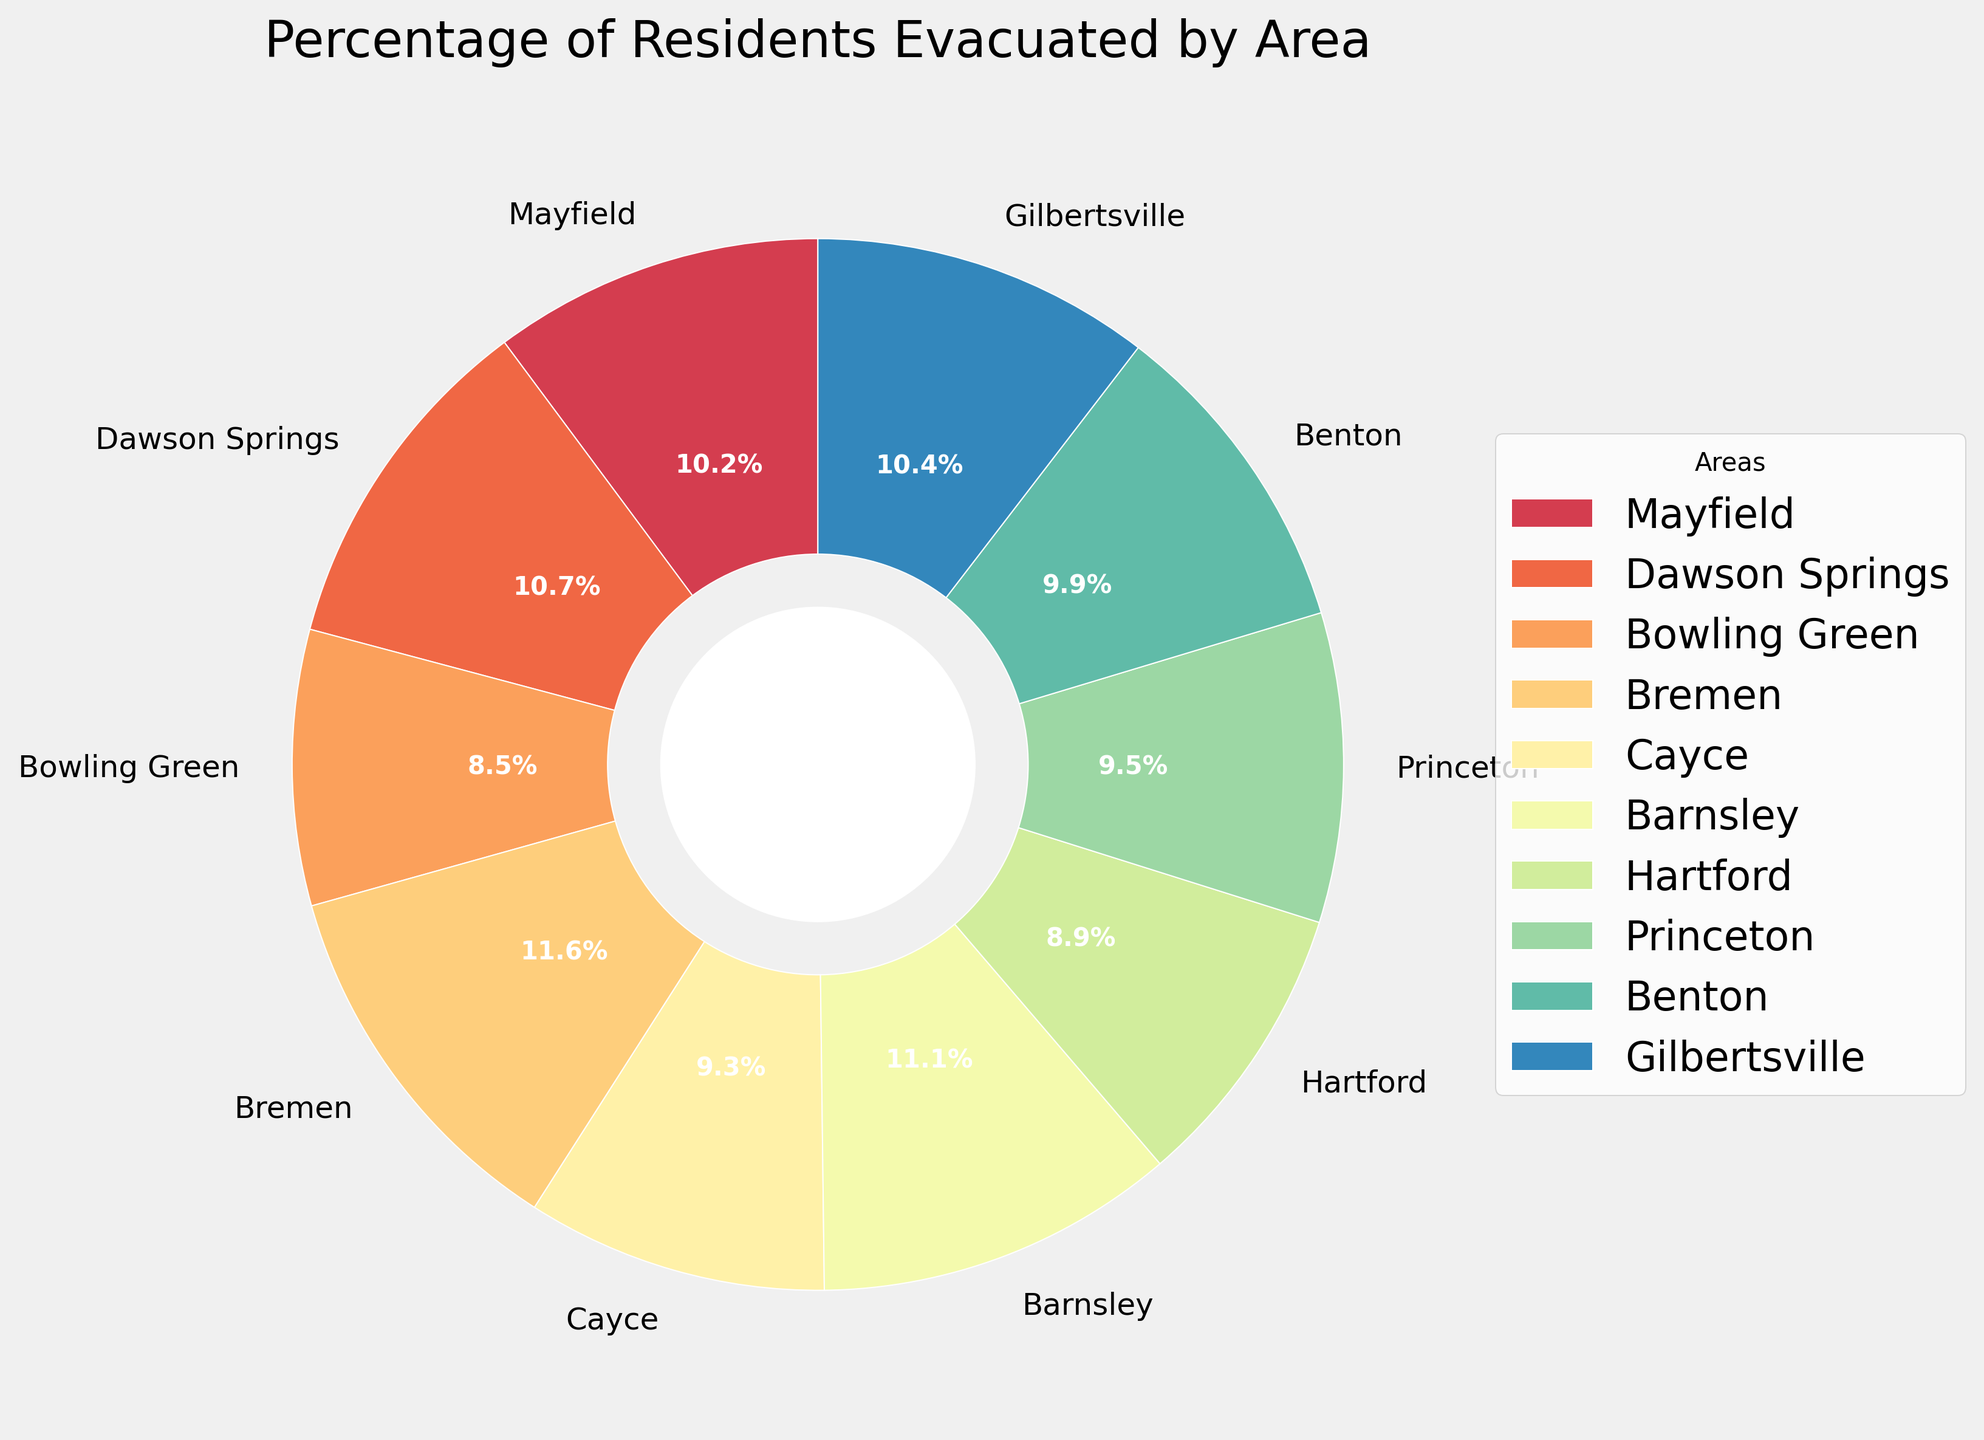Which area has the highest percentage of residents who evacuated? The highest percentage can be identified by observing the largest wedge on the pie chart. Bremen has the largest wedge, indicating the highest percentage of evacuations at 89%.
Answer: Bremen Which area has the lowest percentage of residents who evacuated? The lowest percentage can be determined by observing the smallest wedge on the pie chart. Bowling Green has the smallest wedge, indicating the lowest percentage of evacuations at 65%.
Answer: Bowling Green How many areas have an evacuation percentage of 80% or above? Observe the wedges and their respective labels to count areas with evacuation percentages of 80% or more. There are four such areas: Dawson Springs (82%), Bremen (89%), Barnsley (85%), and Gilbertsville (80%).
Answer: 4 What is the average percentage of residents who evacuated across all areas? Sum all the percentages and then divide by the number of areas. The sum is 78 + 82 + 65 + 89 + 71 + 85 + 68 + 73 + 76 + 80 = 767. There are 10 areas, so the average is 767/10 = 76.7%.
Answer: 76.7% Is the percentage of residents who evacuated from Mayfield greater than that of Princeton and Benton combined? Mayfield has 78%. Princeton has 73% and Benton has 76%, combinedly 73 + 76 = 149%. 78% is not greater than 149%.
Answer: No What is the difference in evacuation percentage between Dawson Springs and Hartford? Dawson Springs has 82% and Hartford has 68%. The difference is 82 - 68 = 14%.
Answer: 14% Is the evacuation percentage from Barnsley less than that of Bremen? Barnsley has 85% and Bremen has 89%. Since 85% is less than 89%, yes, Barnsley has a lower evacuation percentage.
Answer: Yes Which area has an evacuation percentage closest to the average percentage of all areas? The average evacuation percentage is 76.7%. Comparing each area's percentage to this value, Princeton at 73% and Benton at 76% are very close. Benton at 76% is closest to the average.
Answer: Benton Are there more areas with evacuation percentages below 75% or above 75%? Count the areas below and above 75%. Below 75%: Bowling Green (65%), Bremen (71%), Hartford (68%), Princeton (73%). Above 75%: Mayfield (78%), Dawson Springs (82%), Bremen (89%), Barnsley (85%), Benton (76%), Gilbertsville (80%). 4 areas below, 6 areas above.
Answer: Above 75% What is the total percentage of residents who evacuated from Mayfield, Barnsley, and Gilbertsville combined? Add the percentages of Mayfield (78%), Barnsley (85%), and Gilbertsville (80%). Total = 78 + 85 + 80 = 243%.
Answer: 243% 